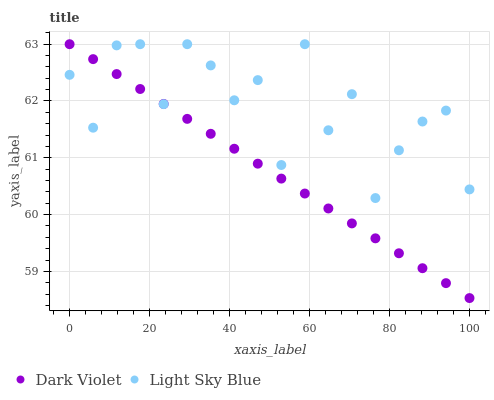Does Dark Violet have the minimum area under the curve?
Answer yes or no. Yes. Does Light Sky Blue have the maximum area under the curve?
Answer yes or no. Yes. Does Dark Violet have the maximum area under the curve?
Answer yes or no. No. Is Dark Violet the smoothest?
Answer yes or no. Yes. Is Light Sky Blue the roughest?
Answer yes or no. Yes. Is Dark Violet the roughest?
Answer yes or no. No. Does Dark Violet have the lowest value?
Answer yes or no. Yes. Does Dark Violet have the highest value?
Answer yes or no. Yes. Does Dark Violet intersect Light Sky Blue?
Answer yes or no. Yes. Is Dark Violet less than Light Sky Blue?
Answer yes or no. No. Is Dark Violet greater than Light Sky Blue?
Answer yes or no. No. 